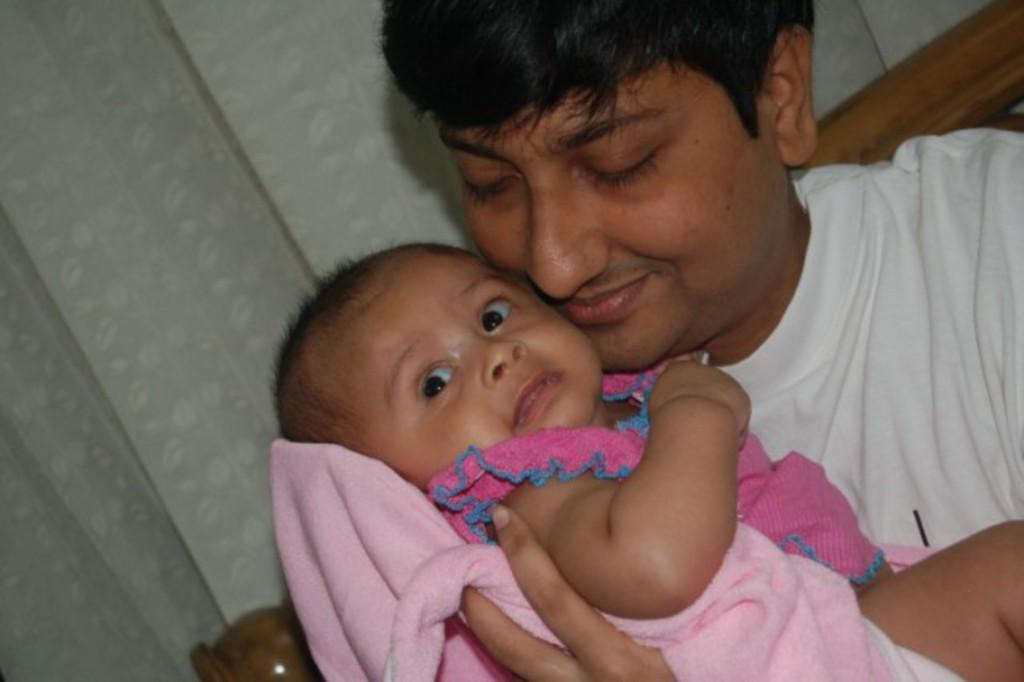What is happening in the center of the image? There is a person holding a baby in the center of the image. What can be seen in the background of the image? There is a curtain and a bed in the background of the image. What type of drum is being played by the baby in the image? There is no drum present in the image, and the baby is not playing any instrument. 